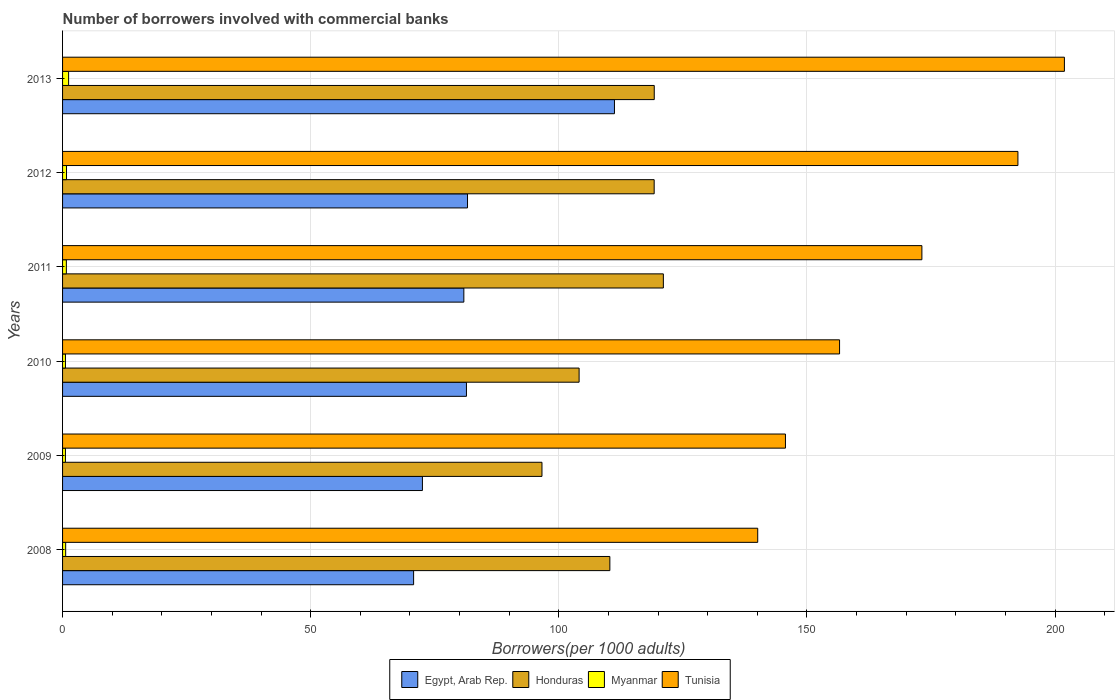How many different coloured bars are there?
Make the answer very short. 4. How many groups of bars are there?
Make the answer very short. 6. How many bars are there on the 1st tick from the top?
Offer a very short reply. 4. How many bars are there on the 6th tick from the bottom?
Give a very brief answer. 4. What is the number of borrowers involved with commercial banks in Egypt, Arab Rep. in 2010?
Your response must be concise. 81.39. Across all years, what is the maximum number of borrowers involved with commercial banks in Egypt, Arab Rep.?
Keep it short and to the point. 111.22. Across all years, what is the minimum number of borrowers involved with commercial banks in Egypt, Arab Rep.?
Keep it short and to the point. 70.74. In which year was the number of borrowers involved with commercial banks in Myanmar minimum?
Your response must be concise. 2009. What is the total number of borrowers involved with commercial banks in Myanmar in the graph?
Keep it short and to the point. 4.56. What is the difference between the number of borrowers involved with commercial banks in Myanmar in 2008 and that in 2011?
Offer a terse response. -0.14. What is the difference between the number of borrowers involved with commercial banks in Honduras in 2008 and the number of borrowers involved with commercial banks in Egypt, Arab Rep. in 2013?
Ensure brevity in your answer.  -0.93. What is the average number of borrowers involved with commercial banks in Myanmar per year?
Your answer should be compact. 0.76. In the year 2011, what is the difference between the number of borrowers involved with commercial banks in Honduras and number of borrowers involved with commercial banks in Tunisia?
Provide a short and direct response. -52.1. What is the ratio of the number of borrowers involved with commercial banks in Tunisia in 2009 to that in 2012?
Offer a very short reply. 0.76. Is the number of borrowers involved with commercial banks in Tunisia in 2011 less than that in 2013?
Offer a terse response. Yes. What is the difference between the highest and the second highest number of borrowers involved with commercial banks in Tunisia?
Offer a very short reply. 9.37. What is the difference between the highest and the lowest number of borrowers involved with commercial banks in Myanmar?
Provide a short and direct response. 0.64. In how many years, is the number of borrowers involved with commercial banks in Tunisia greater than the average number of borrowers involved with commercial banks in Tunisia taken over all years?
Provide a short and direct response. 3. Is the sum of the number of borrowers involved with commercial banks in Tunisia in 2011 and 2012 greater than the maximum number of borrowers involved with commercial banks in Egypt, Arab Rep. across all years?
Provide a succinct answer. Yes. What does the 4th bar from the top in 2012 represents?
Your answer should be compact. Egypt, Arab Rep. What does the 2nd bar from the bottom in 2013 represents?
Your answer should be very brief. Honduras. Is it the case that in every year, the sum of the number of borrowers involved with commercial banks in Myanmar and number of borrowers involved with commercial banks in Tunisia is greater than the number of borrowers involved with commercial banks in Egypt, Arab Rep.?
Keep it short and to the point. Yes. How many years are there in the graph?
Your response must be concise. 6. What is the difference between two consecutive major ticks on the X-axis?
Keep it short and to the point. 50. Are the values on the major ticks of X-axis written in scientific E-notation?
Your answer should be very brief. No. What is the title of the graph?
Ensure brevity in your answer.  Number of borrowers involved with commercial banks. What is the label or title of the X-axis?
Keep it short and to the point. Borrowers(per 1000 adults). What is the Borrowers(per 1000 adults) of Egypt, Arab Rep. in 2008?
Offer a very short reply. 70.74. What is the Borrowers(per 1000 adults) of Honduras in 2008?
Provide a succinct answer. 110.29. What is the Borrowers(per 1000 adults) of Myanmar in 2008?
Your answer should be compact. 0.63. What is the Borrowers(per 1000 adults) in Tunisia in 2008?
Keep it short and to the point. 140.09. What is the Borrowers(per 1000 adults) of Egypt, Arab Rep. in 2009?
Ensure brevity in your answer.  72.52. What is the Borrowers(per 1000 adults) of Honduras in 2009?
Provide a succinct answer. 96.61. What is the Borrowers(per 1000 adults) of Myanmar in 2009?
Give a very brief answer. 0.58. What is the Borrowers(per 1000 adults) of Tunisia in 2009?
Offer a terse response. 145.68. What is the Borrowers(per 1000 adults) of Egypt, Arab Rep. in 2010?
Keep it short and to the point. 81.39. What is the Borrowers(per 1000 adults) in Honduras in 2010?
Ensure brevity in your answer.  104.09. What is the Borrowers(per 1000 adults) of Myanmar in 2010?
Make the answer very short. 0.58. What is the Borrowers(per 1000 adults) in Tunisia in 2010?
Your answer should be compact. 156.58. What is the Borrowers(per 1000 adults) in Egypt, Arab Rep. in 2011?
Your response must be concise. 80.87. What is the Borrowers(per 1000 adults) of Honduras in 2011?
Give a very brief answer. 121.07. What is the Borrowers(per 1000 adults) in Myanmar in 2011?
Your answer should be very brief. 0.76. What is the Borrowers(per 1000 adults) in Tunisia in 2011?
Provide a short and direct response. 173.17. What is the Borrowers(per 1000 adults) of Egypt, Arab Rep. in 2012?
Offer a terse response. 81.61. What is the Borrowers(per 1000 adults) in Honduras in 2012?
Provide a short and direct response. 119.22. What is the Borrowers(per 1000 adults) in Myanmar in 2012?
Give a very brief answer. 0.8. What is the Borrowers(per 1000 adults) in Tunisia in 2012?
Your answer should be very brief. 192.52. What is the Borrowers(per 1000 adults) in Egypt, Arab Rep. in 2013?
Ensure brevity in your answer.  111.22. What is the Borrowers(per 1000 adults) of Honduras in 2013?
Your answer should be very brief. 119.24. What is the Borrowers(per 1000 adults) of Myanmar in 2013?
Give a very brief answer. 1.22. What is the Borrowers(per 1000 adults) of Tunisia in 2013?
Make the answer very short. 201.89. Across all years, what is the maximum Borrowers(per 1000 adults) of Egypt, Arab Rep.?
Ensure brevity in your answer.  111.22. Across all years, what is the maximum Borrowers(per 1000 adults) of Honduras?
Keep it short and to the point. 121.07. Across all years, what is the maximum Borrowers(per 1000 adults) of Myanmar?
Your response must be concise. 1.22. Across all years, what is the maximum Borrowers(per 1000 adults) in Tunisia?
Provide a succinct answer. 201.89. Across all years, what is the minimum Borrowers(per 1000 adults) of Egypt, Arab Rep.?
Give a very brief answer. 70.74. Across all years, what is the minimum Borrowers(per 1000 adults) in Honduras?
Provide a short and direct response. 96.61. Across all years, what is the minimum Borrowers(per 1000 adults) in Myanmar?
Ensure brevity in your answer.  0.58. Across all years, what is the minimum Borrowers(per 1000 adults) of Tunisia?
Provide a succinct answer. 140.09. What is the total Borrowers(per 1000 adults) in Egypt, Arab Rep. in the graph?
Your response must be concise. 498.34. What is the total Borrowers(per 1000 adults) of Honduras in the graph?
Your response must be concise. 670.52. What is the total Borrowers(per 1000 adults) in Myanmar in the graph?
Your answer should be compact. 4.56. What is the total Borrowers(per 1000 adults) of Tunisia in the graph?
Offer a very short reply. 1009.93. What is the difference between the Borrowers(per 1000 adults) of Egypt, Arab Rep. in 2008 and that in 2009?
Offer a very short reply. -1.78. What is the difference between the Borrowers(per 1000 adults) of Honduras in 2008 and that in 2009?
Ensure brevity in your answer.  13.68. What is the difference between the Borrowers(per 1000 adults) in Myanmar in 2008 and that in 2009?
Make the answer very short. 0.05. What is the difference between the Borrowers(per 1000 adults) in Tunisia in 2008 and that in 2009?
Offer a terse response. -5.59. What is the difference between the Borrowers(per 1000 adults) in Egypt, Arab Rep. in 2008 and that in 2010?
Provide a succinct answer. -10.65. What is the difference between the Borrowers(per 1000 adults) in Honduras in 2008 and that in 2010?
Ensure brevity in your answer.  6.2. What is the difference between the Borrowers(per 1000 adults) of Myanmar in 2008 and that in 2010?
Provide a short and direct response. 0.04. What is the difference between the Borrowers(per 1000 adults) in Tunisia in 2008 and that in 2010?
Provide a succinct answer. -16.49. What is the difference between the Borrowers(per 1000 adults) in Egypt, Arab Rep. in 2008 and that in 2011?
Make the answer very short. -10.12. What is the difference between the Borrowers(per 1000 adults) of Honduras in 2008 and that in 2011?
Your answer should be very brief. -10.78. What is the difference between the Borrowers(per 1000 adults) in Myanmar in 2008 and that in 2011?
Ensure brevity in your answer.  -0.14. What is the difference between the Borrowers(per 1000 adults) of Tunisia in 2008 and that in 2011?
Give a very brief answer. -33.08. What is the difference between the Borrowers(per 1000 adults) in Egypt, Arab Rep. in 2008 and that in 2012?
Your response must be concise. -10.86. What is the difference between the Borrowers(per 1000 adults) in Honduras in 2008 and that in 2012?
Offer a terse response. -8.93. What is the difference between the Borrowers(per 1000 adults) in Myanmar in 2008 and that in 2012?
Your answer should be compact. -0.17. What is the difference between the Borrowers(per 1000 adults) in Tunisia in 2008 and that in 2012?
Your answer should be very brief. -52.43. What is the difference between the Borrowers(per 1000 adults) in Egypt, Arab Rep. in 2008 and that in 2013?
Your response must be concise. -40.47. What is the difference between the Borrowers(per 1000 adults) in Honduras in 2008 and that in 2013?
Give a very brief answer. -8.95. What is the difference between the Borrowers(per 1000 adults) of Myanmar in 2008 and that in 2013?
Provide a short and direct response. -0.59. What is the difference between the Borrowers(per 1000 adults) in Tunisia in 2008 and that in 2013?
Give a very brief answer. -61.8. What is the difference between the Borrowers(per 1000 adults) of Egypt, Arab Rep. in 2009 and that in 2010?
Give a very brief answer. -8.87. What is the difference between the Borrowers(per 1000 adults) in Honduras in 2009 and that in 2010?
Your response must be concise. -7.48. What is the difference between the Borrowers(per 1000 adults) of Myanmar in 2009 and that in 2010?
Make the answer very short. -0. What is the difference between the Borrowers(per 1000 adults) of Tunisia in 2009 and that in 2010?
Provide a succinct answer. -10.9. What is the difference between the Borrowers(per 1000 adults) of Egypt, Arab Rep. in 2009 and that in 2011?
Ensure brevity in your answer.  -8.35. What is the difference between the Borrowers(per 1000 adults) in Honduras in 2009 and that in 2011?
Offer a terse response. -24.46. What is the difference between the Borrowers(per 1000 adults) of Myanmar in 2009 and that in 2011?
Your response must be concise. -0.19. What is the difference between the Borrowers(per 1000 adults) in Tunisia in 2009 and that in 2011?
Your answer should be very brief. -27.5. What is the difference between the Borrowers(per 1000 adults) in Egypt, Arab Rep. in 2009 and that in 2012?
Ensure brevity in your answer.  -9.09. What is the difference between the Borrowers(per 1000 adults) in Honduras in 2009 and that in 2012?
Your response must be concise. -22.61. What is the difference between the Borrowers(per 1000 adults) of Myanmar in 2009 and that in 2012?
Offer a very short reply. -0.22. What is the difference between the Borrowers(per 1000 adults) of Tunisia in 2009 and that in 2012?
Give a very brief answer. -46.85. What is the difference between the Borrowers(per 1000 adults) of Egypt, Arab Rep. in 2009 and that in 2013?
Offer a terse response. -38.7. What is the difference between the Borrowers(per 1000 adults) in Honduras in 2009 and that in 2013?
Make the answer very short. -22.63. What is the difference between the Borrowers(per 1000 adults) in Myanmar in 2009 and that in 2013?
Your answer should be very brief. -0.64. What is the difference between the Borrowers(per 1000 adults) in Tunisia in 2009 and that in 2013?
Your response must be concise. -56.21. What is the difference between the Borrowers(per 1000 adults) of Egypt, Arab Rep. in 2010 and that in 2011?
Make the answer very short. 0.52. What is the difference between the Borrowers(per 1000 adults) in Honduras in 2010 and that in 2011?
Your answer should be very brief. -16.98. What is the difference between the Borrowers(per 1000 adults) in Myanmar in 2010 and that in 2011?
Your response must be concise. -0.18. What is the difference between the Borrowers(per 1000 adults) in Tunisia in 2010 and that in 2011?
Make the answer very short. -16.59. What is the difference between the Borrowers(per 1000 adults) in Egypt, Arab Rep. in 2010 and that in 2012?
Provide a short and direct response. -0.21. What is the difference between the Borrowers(per 1000 adults) in Honduras in 2010 and that in 2012?
Make the answer very short. -15.13. What is the difference between the Borrowers(per 1000 adults) of Myanmar in 2010 and that in 2012?
Make the answer very short. -0.21. What is the difference between the Borrowers(per 1000 adults) in Tunisia in 2010 and that in 2012?
Offer a terse response. -35.94. What is the difference between the Borrowers(per 1000 adults) of Egypt, Arab Rep. in 2010 and that in 2013?
Keep it short and to the point. -29.82. What is the difference between the Borrowers(per 1000 adults) of Honduras in 2010 and that in 2013?
Your answer should be very brief. -15.14. What is the difference between the Borrowers(per 1000 adults) in Myanmar in 2010 and that in 2013?
Give a very brief answer. -0.64. What is the difference between the Borrowers(per 1000 adults) of Tunisia in 2010 and that in 2013?
Offer a very short reply. -45.31. What is the difference between the Borrowers(per 1000 adults) in Egypt, Arab Rep. in 2011 and that in 2012?
Offer a terse response. -0.74. What is the difference between the Borrowers(per 1000 adults) in Honduras in 2011 and that in 2012?
Give a very brief answer. 1.85. What is the difference between the Borrowers(per 1000 adults) in Myanmar in 2011 and that in 2012?
Ensure brevity in your answer.  -0.03. What is the difference between the Borrowers(per 1000 adults) in Tunisia in 2011 and that in 2012?
Provide a short and direct response. -19.35. What is the difference between the Borrowers(per 1000 adults) in Egypt, Arab Rep. in 2011 and that in 2013?
Your answer should be very brief. -30.35. What is the difference between the Borrowers(per 1000 adults) of Honduras in 2011 and that in 2013?
Keep it short and to the point. 1.84. What is the difference between the Borrowers(per 1000 adults) of Myanmar in 2011 and that in 2013?
Provide a short and direct response. -0.45. What is the difference between the Borrowers(per 1000 adults) in Tunisia in 2011 and that in 2013?
Offer a terse response. -28.72. What is the difference between the Borrowers(per 1000 adults) in Egypt, Arab Rep. in 2012 and that in 2013?
Offer a terse response. -29.61. What is the difference between the Borrowers(per 1000 adults) in Honduras in 2012 and that in 2013?
Your answer should be very brief. -0.02. What is the difference between the Borrowers(per 1000 adults) in Myanmar in 2012 and that in 2013?
Provide a short and direct response. -0.42. What is the difference between the Borrowers(per 1000 adults) in Tunisia in 2012 and that in 2013?
Your answer should be compact. -9.37. What is the difference between the Borrowers(per 1000 adults) of Egypt, Arab Rep. in 2008 and the Borrowers(per 1000 adults) of Honduras in 2009?
Offer a very short reply. -25.87. What is the difference between the Borrowers(per 1000 adults) in Egypt, Arab Rep. in 2008 and the Borrowers(per 1000 adults) in Myanmar in 2009?
Make the answer very short. 70.17. What is the difference between the Borrowers(per 1000 adults) in Egypt, Arab Rep. in 2008 and the Borrowers(per 1000 adults) in Tunisia in 2009?
Provide a succinct answer. -74.93. What is the difference between the Borrowers(per 1000 adults) in Honduras in 2008 and the Borrowers(per 1000 adults) in Myanmar in 2009?
Offer a terse response. 109.71. What is the difference between the Borrowers(per 1000 adults) in Honduras in 2008 and the Borrowers(per 1000 adults) in Tunisia in 2009?
Keep it short and to the point. -35.38. What is the difference between the Borrowers(per 1000 adults) in Myanmar in 2008 and the Borrowers(per 1000 adults) in Tunisia in 2009?
Offer a very short reply. -145.05. What is the difference between the Borrowers(per 1000 adults) in Egypt, Arab Rep. in 2008 and the Borrowers(per 1000 adults) in Honduras in 2010?
Make the answer very short. -33.35. What is the difference between the Borrowers(per 1000 adults) in Egypt, Arab Rep. in 2008 and the Borrowers(per 1000 adults) in Myanmar in 2010?
Give a very brief answer. 70.16. What is the difference between the Borrowers(per 1000 adults) in Egypt, Arab Rep. in 2008 and the Borrowers(per 1000 adults) in Tunisia in 2010?
Give a very brief answer. -85.84. What is the difference between the Borrowers(per 1000 adults) of Honduras in 2008 and the Borrowers(per 1000 adults) of Myanmar in 2010?
Offer a terse response. 109.71. What is the difference between the Borrowers(per 1000 adults) of Honduras in 2008 and the Borrowers(per 1000 adults) of Tunisia in 2010?
Give a very brief answer. -46.29. What is the difference between the Borrowers(per 1000 adults) of Myanmar in 2008 and the Borrowers(per 1000 adults) of Tunisia in 2010?
Your response must be concise. -155.95. What is the difference between the Borrowers(per 1000 adults) in Egypt, Arab Rep. in 2008 and the Borrowers(per 1000 adults) in Honduras in 2011?
Your answer should be compact. -50.33. What is the difference between the Borrowers(per 1000 adults) of Egypt, Arab Rep. in 2008 and the Borrowers(per 1000 adults) of Myanmar in 2011?
Give a very brief answer. 69.98. What is the difference between the Borrowers(per 1000 adults) of Egypt, Arab Rep. in 2008 and the Borrowers(per 1000 adults) of Tunisia in 2011?
Ensure brevity in your answer.  -102.43. What is the difference between the Borrowers(per 1000 adults) of Honduras in 2008 and the Borrowers(per 1000 adults) of Myanmar in 2011?
Provide a short and direct response. 109.53. What is the difference between the Borrowers(per 1000 adults) in Honduras in 2008 and the Borrowers(per 1000 adults) in Tunisia in 2011?
Offer a terse response. -62.88. What is the difference between the Borrowers(per 1000 adults) in Myanmar in 2008 and the Borrowers(per 1000 adults) in Tunisia in 2011?
Offer a very short reply. -172.55. What is the difference between the Borrowers(per 1000 adults) in Egypt, Arab Rep. in 2008 and the Borrowers(per 1000 adults) in Honduras in 2012?
Provide a succinct answer. -48.48. What is the difference between the Borrowers(per 1000 adults) of Egypt, Arab Rep. in 2008 and the Borrowers(per 1000 adults) of Myanmar in 2012?
Provide a short and direct response. 69.95. What is the difference between the Borrowers(per 1000 adults) in Egypt, Arab Rep. in 2008 and the Borrowers(per 1000 adults) in Tunisia in 2012?
Ensure brevity in your answer.  -121.78. What is the difference between the Borrowers(per 1000 adults) in Honduras in 2008 and the Borrowers(per 1000 adults) in Myanmar in 2012?
Ensure brevity in your answer.  109.49. What is the difference between the Borrowers(per 1000 adults) in Honduras in 2008 and the Borrowers(per 1000 adults) in Tunisia in 2012?
Provide a short and direct response. -82.23. What is the difference between the Borrowers(per 1000 adults) in Myanmar in 2008 and the Borrowers(per 1000 adults) in Tunisia in 2012?
Make the answer very short. -191.9. What is the difference between the Borrowers(per 1000 adults) in Egypt, Arab Rep. in 2008 and the Borrowers(per 1000 adults) in Honduras in 2013?
Offer a very short reply. -48.49. What is the difference between the Borrowers(per 1000 adults) of Egypt, Arab Rep. in 2008 and the Borrowers(per 1000 adults) of Myanmar in 2013?
Offer a very short reply. 69.53. What is the difference between the Borrowers(per 1000 adults) of Egypt, Arab Rep. in 2008 and the Borrowers(per 1000 adults) of Tunisia in 2013?
Offer a terse response. -131.15. What is the difference between the Borrowers(per 1000 adults) of Honduras in 2008 and the Borrowers(per 1000 adults) of Myanmar in 2013?
Your answer should be compact. 109.07. What is the difference between the Borrowers(per 1000 adults) of Honduras in 2008 and the Borrowers(per 1000 adults) of Tunisia in 2013?
Offer a terse response. -91.6. What is the difference between the Borrowers(per 1000 adults) in Myanmar in 2008 and the Borrowers(per 1000 adults) in Tunisia in 2013?
Provide a succinct answer. -201.26. What is the difference between the Borrowers(per 1000 adults) in Egypt, Arab Rep. in 2009 and the Borrowers(per 1000 adults) in Honduras in 2010?
Give a very brief answer. -31.57. What is the difference between the Borrowers(per 1000 adults) in Egypt, Arab Rep. in 2009 and the Borrowers(per 1000 adults) in Myanmar in 2010?
Your answer should be very brief. 71.94. What is the difference between the Borrowers(per 1000 adults) of Egypt, Arab Rep. in 2009 and the Borrowers(per 1000 adults) of Tunisia in 2010?
Offer a terse response. -84.06. What is the difference between the Borrowers(per 1000 adults) in Honduras in 2009 and the Borrowers(per 1000 adults) in Myanmar in 2010?
Your answer should be compact. 96.03. What is the difference between the Borrowers(per 1000 adults) of Honduras in 2009 and the Borrowers(per 1000 adults) of Tunisia in 2010?
Offer a very short reply. -59.97. What is the difference between the Borrowers(per 1000 adults) of Myanmar in 2009 and the Borrowers(per 1000 adults) of Tunisia in 2010?
Provide a short and direct response. -156. What is the difference between the Borrowers(per 1000 adults) of Egypt, Arab Rep. in 2009 and the Borrowers(per 1000 adults) of Honduras in 2011?
Your response must be concise. -48.55. What is the difference between the Borrowers(per 1000 adults) of Egypt, Arab Rep. in 2009 and the Borrowers(per 1000 adults) of Myanmar in 2011?
Make the answer very short. 71.75. What is the difference between the Borrowers(per 1000 adults) of Egypt, Arab Rep. in 2009 and the Borrowers(per 1000 adults) of Tunisia in 2011?
Your answer should be very brief. -100.65. What is the difference between the Borrowers(per 1000 adults) in Honduras in 2009 and the Borrowers(per 1000 adults) in Myanmar in 2011?
Your response must be concise. 95.84. What is the difference between the Borrowers(per 1000 adults) in Honduras in 2009 and the Borrowers(per 1000 adults) in Tunisia in 2011?
Make the answer very short. -76.56. What is the difference between the Borrowers(per 1000 adults) in Myanmar in 2009 and the Borrowers(per 1000 adults) in Tunisia in 2011?
Your answer should be compact. -172.59. What is the difference between the Borrowers(per 1000 adults) in Egypt, Arab Rep. in 2009 and the Borrowers(per 1000 adults) in Honduras in 2012?
Your answer should be compact. -46.7. What is the difference between the Borrowers(per 1000 adults) of Egypt, Arab Rep. in 2009 and the Borrowers(per 1000 adults) of Myanmar in 2012?
Your response must be concise. 71.72. What is the difference between the Borrowers(per 1000 adults) in Egypt, Arab Rep. in 2009 and the Borrowers(per 1000 adults) in Tunisia in 2012?
Offer a very short reply. -120. What is the difference between the Borrowers(per 1000 adults) of Honduras in 2009 and the Borrowers(per 1000 adults) of Myanmar in 2012?
Provide a short and direct response. 95.81. What is the difference between the Borrowers(per 1000 adults) of Honduras in 2009 and the Borrowers(per 1000 adults) of Tunisia in 2012?
Give a very brief answer. -95.91. What is the difference between the Borrowers(per 1000 adults) of Myanmar in 2009 and the Borrowers(per 1000 adults) of Tunisia in 2012?
Give a very brief answer. -191.95. What is the difference between the Borrowers(per 1000 adults) of Egypt, Arab Rep. in 2009 and the Borrowers(per 1000 adults) of Honduras in 2013?
Keep it short and to the point. -46.72. What is the difference between the Borrowers(per 1000 adults) of Egypt, Arab Rep. in 2009 and the Borrowers(per 1000 adults) of Myanmar in 2013?
Ensure brevity in your answer.  71.3. What is the difference between the Borrowers(per 1000 adults) in Egypt, Arab Rep. in 2009 and the Borrowers(per 1000 adults) in Tunisia in 2013?
Provide a succinct answer. -129.37. What is the difference between the Borrowers(per 1000 adults) in Honduras in 2009 and the Borrowers(per 1000 adults) in Myanmar in 2013?
Your response must be concise. 95.39. What is the difference between the Borrowers(per 1000 adults) of Honduras in 2009 and the Borrowers(per 1000 adults) of Tunisia in 2013?
Your answer should be compact. -105.28. What is the difference between the Borrowers(per 1000 adults) of Myanmar in 2009 and the Borrowers(per 1000 adults) of Tunisia in 2013?
Ensure brevity in your answer.  -201.31. What is the difference between the Borrowers(per 1000 adults) in Egypt, Arab Rep. in 2010 and the Borrowers(per 1000 adults) in Honduras in 2011?
Your answer should be compact. -39.68. What is the difference between the Borrowers(per 1000 adults) in Egypt, Arab Rep. in 2010 and the Borrowers(per 1000 adults) in Myanmar in 2011?
Your response must be concise. 80.63. What is the difference between the Borrowers(per 1000 adults) of Egypt, Arab Rep. in 2010 and the Borrowers(per 1000 adults) of Tunisia in 2011?
Your answer should be compact. -91.78. What is the difference between the Borrowers(per 1000 adults) of Honduras in 2010 and the Borrowers(per 1000 adults) of Myanmar in 2011?
Provide a succinct answer. 103.33. What is the difference between the Borrowers(per 1000 adults) in Honduras in 2010 and the Borrowers(per 1000 adults) in Tunisia in 2011?
Give a very brief answer. -69.08. What is the difference between the Borrowers(per 1000 adults) in Myanmar in 2010 and the Borrowers(per 1000 adults) in Tunisia in 2011?
Give a very brief answer. -172.59. What is the difference between the Borrowers(per 1000 adults) in Egypt, Arab Rep. in 2010 and the Borrowers(per 1000 adults) in Honduras in 2012?
Your answer should be compact. -37.83. What is the difference between the Borrowers(per 1000 adults) in Egypt, Arab Rep. in 2010 and the Borrowers(per 1000 adults) in Myanmar in 2012?
Offer a terse response. 80.59. What is the difference between the Borrowers(per 1000 adults) in Egypt, Arab Rep. in 2010 and the Borrowers(per 1000 adults) in Tunisia in 2012?
Keep it short and to the point. -111.13. What is the difference between the Borrowers(per 1000 adults) in Honduras in 2010 and the Borrowers(per 1000 adults) in Myanmar in 2012?
Ensure brevity in your answer.  103.3. What is the difference between the Borrowers(per 1000 adults) of Honduras in 2010 and the Borrowers(per 1000 adults) of Tunisia in 2012?
Your response must be concise. -88.43. What is the difference between the Borrowers(per 1000 adults) of Myanmar in 2010 and the Borrowers(per 1000 adults) of Tunisia in 2012?
Keep it short and to the point. -191.94. What is the difference between the Borrowers(per 1000 adults) in Egypt, Arab Rep. in 2010 and the Borrowers(per 1000 adults) in Honduras in 2013?
Ensure brevity in your answer.  -37.85. What is the difference between the Borrowers(per 1000 adults) in Egypt, Arab Rep. in 2010 and the Borrowers(per 1000 adults) in Myanmar in 2013?
Offer a terse response. 80.17. What is the difference between the Borrowers(per 1000 adults) of Egypt, Arab Rep. in 2010 and the Borrowers(per 1000 adults) of Tunisia in 2013?
Your answer should be compact. -120.5. What is the difference between the Borrowers(per 1000 adults) in Honduras in 2010 and the Borrowers(per 1000 adults) in Myanmar in 2013?
Offer a very short reply. 102.88. What is the difference between the Borrowers(per 1000 adults) of Honduras in 2010 and the Borrowers(per 1000 adults) of Tunisia in 2013?
Your answer should be compact. -97.8. What is the difference between the Borrowers(per 1000 adults) in Myanmar in 2010 and the Borrowers(per 1000 adults) in Tunisia in 2013?
Keep it short and to the point. -201.31. What is the difference between the Borrowers(per 1000 adults) of Egypt, Arab Rep. in 2011 and the Borrowers(per 1000 adults) of Honduras in 2012?
Ensure brevity in your answer.  -38.35. What is the difference between the Borrowers(per 1000 adults) in Egypt, Arab Rep. in 2011 and the Borrowers(per 1000 adults) in Myanmar in 2012?
Ensure brevity in your answer.  80.07. What is the difference between the Borrowers(per 1000 adults) of Egypt, Arab Rep. in 2011 and the Borrowers(per 1000 adults) of Tunisia in 2012?
Offer a terse response. -111.66. What is the difference between the Borrowers(per 1000 adults) of Honduras in 2011 and the Borrowers(per 1000 adults) of Myanmar in 2012?
Your answer should be very brief. 120.28. What is the difference between the Borrowers(per 1000 adults) of Honduras in 2011 and the Borrowers(per 1000 adults) of Tunisia in 2012?
Provide a short and direct response. -71.45. What is the difference between the Borrowers(per 1000 adults) of Myanmar in 2011 and the Borrowers(per 1000 adults) of Tunisia in 2012?
Provide a succinct answer. -191.76. What is the difference between the Borrowers(per 1000 adults) in Egypt, Arab Rep. in 2011 and the Borrowers(per 1000 adults) in Honduras in 2013?
Keep it short and to the point. -38.37. What is the difference between the Borrowers(per 1000 adults) of Egypt, Arab Rep. in 2011 and the Borrowers(per 1000 adults) of Myanmar in 2013?
Your answer should be very brief. 79.65. What is the difference between the Borrowers(per 1000 adults) in Egypt, Arab Rep. in 2011 and the Borrowers(per 1000 adults) in Tunisia in 2013?
Ensure brevity in your answer.  -121.02. What is the difference between the Borrowers(per 1000 adults) in Honduras in 2011 and the Borrowers(per 1000 adults) in Myanmar in 2013?
Ensure brevity in your answer.  119.86. What is the difference between the Borrowers(per 1000 adults) of Honduras in 2011 and the Borrowers(per 1000 adults) of Tunisia in 2013?
Offer a terse response. -80.82. What is the difference between the Borrowers(per 1000 adults) in Myanmar in 2011 and the Borrowers(per 1000 adults) in Tunisia in 2013?
Keep it short and to the point. -201.13. What is the difference between the Borrowers(per 1000 adults) in Egypt, Arab Rep. in 2012 and the Borrowers(per 1000 adults) in Honduras in 2013?
Your response must be concise. -37.63. What is the difference between the Borrowers(per 1000 adults) in Egypt, Arab Rep. in 2012 and the Borrowers(per 1000 adults) in Myanmar in 2013?
Provide a succinct answer. 80.39. What is the difference between the Borrowers(per 1000 adults) of Egypt, Arab Rep. in 2012 and the Borrowers(per 1000 adults) of Tunisia in 2013?
Offer a very short reply. -120.28. What is the difference between the Borrowers(per 1000 adults) in Honduras in 2012 and the Borrowers(per 1000 adults) in Myanmar in 2013?
Your answer should be very brief. 118. What is the difference between the Borrowers(per 1000 adults) in Honduras in 2012 and the Borrowers(per 1000 adults) in Tunisia in 2013?
Your answer should be very brief. -82.67. What is the difference between the Borrowers(per 1000 adults) of Myanmar in 2012 and the Borrowers(per 1000 adults) of Tunisia in 2013?
Your response must be concise. -201.09. What is the average Borrowers(per 1000 adults) in Egypt, Arab Rep. per year?
Make the answer very short. 83.06. What is the average Borrowers(per 1000 adults) of Honduras per year?
Provide a short and direct response. 111.75. What is the average Borrowers(per 1000 adults) of Myanmar per year?
Provide a succinct answer. 0.76. What is the average Borrowers(per 1000 adults) of Tunisia per year?
Your answer should be very brief. 168.32. In the year 2008, what is the difference between the Borrowers(per 1000 adults) of Egypt, Arab Rep. and Borrowers(per 1000 adults) of Honduras?
Ensure brevity in your answer.  -39.55. In the year 2008, what is the difference between the Borrowers(per 1000 adults) in Egypt, Arab Rep. and Borrowers(per 1000 adults) in Myanmar?
Provide a succinct answer. 70.12. In the year 2008, what is the difference between the Borrowers(per 1000 adults) of Egypt, Arab Rep. and Borrowers(per 1000 adults) of Tunisia?
Your answer should be compact. -69.34. In the year 2008, what is the difference between the Borrowers(per 1000 adults) of Honduras and Borrowers(per 1000 adults) of Myanmar?
Keep it short and to the point. 109.66. In the year 2008, what is the difference between the Borrowers(per 1000 adults) in Honduras and Borrowers(per 1000 adults) in Tunisia?
Make the answer very short. -29.8. In the year 2008, what is the difference between the Borrowers(per 1000 adults) of Myanmar and Borrowers(per 1000 adults) of Tunisia?
Offer a terse response. -139.46. In the year 2009, what is the difference between the Borrowers(per 1000 adults) in Egypt, Arab Rep. and Borrowers(per 1000 adults) in Honduras?
Offer a terse response. -24.09. In the year 2009, what is the difference between the Borrowers(per 1000 adults) of Egypt, Arab Rep. and Borrowers(per 1000 adults) of Myanmar?
Your answer should be very brief. 71.94. In the year 2009, what is the difference between the Borrowers(per 1000 adults) in Egypt, Arab Rep. and Borrowers(per 1000 adults) in Tunisia?
Give a very brief answer. -73.16. In the year 2009, what is the difference between the Borrowers(per 1000 adults) of Honduras and Borrowers(per 1000 adults) of Myanmar?
Provide a succinct answer. 96.03. In the year 2009, what is the difference between the Borrowers(per 1000 adults) in Honduras and Borrowers(per 1000 adults) in Tunisia?
Your answer should be compact. -49.07. In the year 2009, what is the difference between the Borrowers(per 1000 adults) in Myanmar and Borrowers(per 1000 adults) in Tunisia?
Give a very brief answer. -145.1. In the year 2010, what is the difference between the Borrowers(per 1000 adults) of Egypt, Arab Rep. and Borrowers(per 1000 adults) of Honduras?
Offer a very short reply. -22.7. In the year 2010, what is the difference between the Borrowers(per 1000 adults) in Egypt, Arab Rep. and Borrowers(per 1000 adults) in Myanmar?
Give a very brief answer. 80.81. In the year 2010, what is the difference between the Borrowers(per 1000 adults) in Egypt, Arab Rep. and Borrowers(per 1000 adults) in Tunisia?
Offer a very short reply. -75.19. In the year 2010, what is the difference between the Borrowers(per 1000 adults) of Honduras and Borrowers(per 1000 adults) of Myanmar?
Ensure brevity in your answer.  103.51. In the year 2010, what is the difference between the Borrowers(per 1000 adults) in Honduras and Borrowers(per 1000 adults) in Tunisia?
Give a very brief answer. -52.49. In the year 2010, what is the difference between the Borrowers(per 1000 adults) in Myanmar and Borrowers(per 1000 adults) in Tunisia?
Your answer should be compact. -156. In the year 2011, what is the difference between the Borrowers(per 1000 adults) of Egypt, Arab Rep. and Borrowers(per 1000 adults) of Honduras?
Keep it short and to the point. -40.21. In the year 2011, what is the difference between the Borrowers(per 1000 adults) in Egypt, Arab Rep. and Borrowers(per 1000 adults) in Myanmar?
Provide a short and direct response. 80.1. In the year 2011, what is the difference between the Borrowers(per 1000 adults) of Egypt, Arab Rep. and Borrowers(per 1000 adults) of Tunisia?
Your answer should be very brief. -92.3. In the year 2011, what is the difference between the Borrowers(per 1000 adults) in Honduras and Borrowers(per 1000 adults) in Myanmar?
Your answer should be compact. 120.31. In the year 2011, what is the difference between the Borrowers(per 1000 adults) in Honduras and Borrowers(per 1000 adults) in Tunisia?
Provide a succinct answer. -52.1. In the year 2011, what is the difference between the Borrowers(per 1000 adults) of Myanmar and Borrowers(per 1000 adults) of Tunisia?
Give a very brief answer. -172.41. In the year 2012, what is the difference between the Borrowers(per 1000 adults) of Egypt, Arab Rep. and Borrowers(per 1000 adults) of Honduras?
Keep it short and to the point. -37.62. In the year 2012, what is the difference between the Borrowers(per 1000 adults) in Egypt, Arab Rep. and Borrowers(per 1000 adults) in Myanmar?
Offer a very short reply. 80.81. In the year 2012, what is the difference between the Borrowers(per 1000 adults) of Egypt, Arab Rep. and Borrowers(per 1000 adults) of Tunisia?
Make the answer very short. -110.92. In the year 2012, what is the difference between the Borrowers(per 1000 adults) of Honduras and Borrowers(per 1000 adults) of Myanmar?
Make the answer very short. 118.43. In the year 2012, what is the difference between the Borrowers(per 1000 adults) in Honduras and Borrowers(per 1000 adults) in Tunisia?
Give a very brief answer. -73.3. In the year 2012, what is the difference between the Borrowers(per 1000 adults) in Myanmar and Borrowers(per 1000 adults) in Tunisia?
Offer a very short reply. -191.73. In the year 2013, what is the difference between the Borrowers(per 1000 adults) of Egypt, Arab Rep. and Borrowers(per 1000 adults) of Honduras?
Ensure brevity in your answer.  -8.02. In the year 2013, what is the difference between the Borrowers(per 1000 adults) of Egypt, Arab Rep. and Borrowers(per 1000 adults) of Myanmar?
Offer a terse response. 110. In the year 2013, what is the difference between the Borrowers(per 1000 adults) of Egypt, Arab Rep. and Borrowers(per 1000 adults) of Tunisia?
Ensure brevity in your answer.  -90.67. In the year 2013, what is the difference between the Borrowers(per 1000 adults) of Honduras and Borrowers(per 1000 adults) of Myanmar?
Keep it short and to the point. 118.02. In the year 2013, what is the difference between the Borrowers(per 1000 adults) of Honduras and Borrowers(per 1000 adults) of Tunisia?
Keep it short and to the point. -82.65. In the year 2013, what is the difference between the Borrowers(per 1000 adults) of Myanmar and Borrowers(per 1000 adults) of Tunisia?
Give a very brief answer. -200.67. What is the ratio of the Borrowers(per 1000 adults) in Egypt, Arab Rep. in 2008 to that in 2009?
Ensure brevity in your answer.  0.98. What is the ratio of the Borrowers(per 1000 adults) in Honduras in 2008 to that in 2009?
Keep it short and to the point. 1.14. What is the ratio of the Borrowers(per 1000 adults) of Myanmar in 2008 to that in 2009?
Offer a very short reply. 1.08. What is the ratio of the Borrowers(per 1000 adults) in Tunisia in 2008 to that in 2009?
Provide a short and direct response. 0.96. What is the ratio of the Borrowers(per 1000 adults) of Egypt, Arab Rep. in 2008 to that in 2010?
Your response must be concise. 0.87. What is the ratio of the Borrowers(per 1000 adults) of Honduras in 2008 to that in 2010?
Give a very brief answer. 1.06. What is the ratio of the Borrowers(per 1000 adults) of Myanmar in 2008 to that in 2010?
Make the answer very short. 1.08. What is the ratio of the Borrowers(per 1000 adults) in Tunisia in 2008 to that in 2010?
Give a very brief answer. 0.89. What is the ratio of the Borrowers(per 1000 adults) in Egypt, Arab Rep. in 2008 to that in 2011?
Ensure brevity in your answer.  0.87. What is the ratio of the Borrowers(per 1000 adults) in Honduras in 2008 to that in 2011?
Provide a succinct answer. 0.91. What is the ratio of the Borrowers(per 1000 adults) in Myanmar in 2008 to that in 2011?
Your answer should be compact. 0.82. What is the ratio of the Borrowers(per 1000 adults) in Tunisia in 2008 to that in 2011?
Provide a succinct answer. 0.81. What is the ratio of the Borrowers(per 1000 adults) of Egypt, Arab Rep. in 2008 to that in 2012?
Your answer should be very brief. 0.87. What is the ratio of the Borrowers(per 1000 adults) in Honduras in 2008 to that in 2012?
Give a very brief answer. 0.93. What is the ratio of the Borrowers(per 1000 adults) of Myanmar in 2008 to that in 2012?
Make the answer very short. 0.79. What is the ratio of the Borrowers(per 1000 adults) of Tunisia in 2008 to that in 2012?
Offer a very short reply. 0.73. What is the ratio of the Borrowers(per 1000 adults) of Egypt, Arab Rep. in 2008 to that in 2013?
Your response must be concise. 0.64. What is the ratio of the Borrowers(per 1000 adults) of Honduras in 2008 to that in 2013?
Your response must be concise. 0.93. What is the ratio of the Borrowers(per 1000 adults) of Myanmar in 2008 to that in 2013?
Make the answer very short. 0.51. What is the ratio of the Borrowers(per 1000 adults) in Tunisia in 2008 to that in 2013?
Give a very brief answer. 0.69. What is the ratio of the Borrowers(per 1000 adults) of Egypt, Arab Rep. in 2009 to that in 2010?
Your answer should be compact. 0.89. What is the ratio of the Borrowers(per 1000 adults) in Honduras in 2009 to that in 2010?
Offer a very short reply. 0.93. What is the ratio of the Borrowers(per 1000 adults) of Myanmar in 2009 to that in 2010?
Offer a terse response. 0.99. What is the ratio of the Borrowers(per 1000 adults) in Tunisia in 2009 to that in 2010?
Keep it short and to the point. 0.93. What is the ratio of the Borrowers(per 1000 adults) of Egypt, Arab Rep. in 2009 to that in 2011?
Ensure brevity in your answer.  0.9. What is the ratio of the Borrowers(per 1000 adults) in Honduras in 2009 to that in 2011?
Offer a very short reply. 0.8. What is the ratio of the Borrowers(per 1000 adults) in Myanmar in 2009 to that in 2011?
Make the answer very short. 0.76. What is the ratio of the Borrowers(per 1000 adults) in Tunisia in 2009 to that in 2011?
Give a very brief answer. 0.84. What is the ratio of the Borrowers(per 1000 adults) of Egypt, Arab Rep. in 2009 to that in 2012?
Make the answer very short. 0.89. What is the ratio of the Borrowers(per 1000 adults) in Honduras in 2009 to that in 2012?
Offer a very short reply. 0.81. What is the ratio of the Borrowers(per 1000 adults) of Myanmar in 2009 to that in 2012?
Ensure brevity in your answer.  0.73. What is the ratio of the Borrowers(per 1000 adults) in Tunisia in 2009 to that in 2012?
Provide a short and direct response. 0.76. What is the ratio of the Borrowers(per 1000 adults) of Egypt, Arab Rep. in 2009 to that in 2013?
Provide a succinct answer. 0.65. What is the ratio of the Borrowers(per 1000 adults) of Honduras in 2009 to that in 2013?
Make the answer very short. 0.81. What is the ratio of the Borrowers(per 1000 adults) in Myanmar in 2009 to that in 2013?
Your answer should be very brief. 0.47. What is the ratio of the Borrowers(per 1000 adults) of Tunisia in 2009 to that in 2013?
Make the answer very short. 0.72. What is the ratio of the Borrowers(per 1000 adults) of Egypt, Arab Rep. in 2010 to that in 2011?
Provide a short and direct response. 1.01. What is the ratio of the Borrowers(per 1000 adults) in Honduras in 2010 to that in 2011?
Provide a short and direct response. 0.86. What is the ratio of the Borrowers(per 1000 adults) in Myanmar in 2010 to that in 2011?
Your response must be concise. 0.76. What is the ratio of the Borrowers(per 1000 adults) in Tunisia in 2010 to that in 2011?
Provide a succinct answer. 0.9. What is the ratio of the Borrowers(per 1000 adults) of Egypt, Arab Rep. in 2010 to that in 2012?
Keep it short and to the point. 1. What is the ratio of the Borrowers(per 1000 adults) in Honduras in 2010 to that in 2012?
Your response must be concise. 0.87. What is the ratio of the Borrowers(per 1000 adults) in Myanmar in 2010 to that in 2012?
Offer a very short reply. 0.73. What is the ratio of the Borrowers(per 1000 adults) of Tunisia in 2010 to that in 2012?
Your response must be concise. 0.81. What is the ratio of the Borrowers(per 1000 adults) of Egypt, Arab Rep. in 2010 to that in 2013?
Offer a very short reply. 0.73. What is the ratio of the Borrowers(per 1000 adults) in Honduras in 2010 to that in 2013?
Keep it short and to the point. 0.87. What is the ratio of the Borrowers(per 1000 adults) of Myanmar in 2010 to that in 2013?
Offer a very short reply. 0.48. What is the ratio of the Borrowers(per 1000 adults) in Tunisia in 2010 to that in 2013?
Your answer should be compact. 0.78. What is the ratio of the Borrowers(per 1000 adults) of Egypt, Arab Rep. in 2011 to that in 2012?
Give a very brief answer. 0.99. What is the ratio of the Borrowers(per 1000 adults) in Honduras in 2011 to that in 2012?
Offer a terse response. 1.02. What is the ratio of the Borrowers(per 1000 adults) of Myanmar in 2011 to that in 2012?
Provide a short and direct response. 0.96. What is the ratio of the Borrowers(per 1000 adults) in Tunisia in 2011 to that in 2012?
Offer a terse response. 0.9. What is the ratio of the Borrowers(per 1000 adults) of Egypt, Arab Rep. in 2011 to that in 2013?
Ensure brevity in your answer.  0.73. What is the ratio of the Borrowers(per 1000 adults) in Honduras in 2011 to that in 2013?
Keep it short and to the point. 1.02. What is the ratio of the Borrowers(per 1000 adults) of Myanmar in 2011 to that in 2013?
Keep it short and to the point. 0.63. What is the ratio of the Borrowers(per 1000 adults) in Tunisia in 2011 to that in 2013?
Offer a terse response. 0.86. What is the ratio of the Borrowers(per 1000 adults) in Egypt, Arab Rep. in 2012 to that in 2013?
Your answer should be compact. 0.73. What is the ratio of the Borrowers(per 1000 adults) in Honduras in 2012 to that in 2013?
Give a very brief answer. 1. What is the ratio of the Borrowers(per 1000 adults) in Myanmar in 2012 to that in 2013?
Keep it short and to the point. 0.65. What is the ratio of the Borrowers(per 1000 adults) in Tunisia in 2012 to that in 2013?
Make the answer very short. 0.95. What is the difference between the highest and the second highest Borrowers(per 1000 adults) of Egypt, Arab Rep.?
Ensure brevity in your answer.  29.61. What is the difference between the highest and the second highest Borrowers(per 1000 adults) of Honduras?
Ensure brevity in your answer.  1.84. What is the difference between the highest and the second highest Borrowers(per 1000 adults) of Myanmar?
Keep it short and to the point. 0.42. What is the difference between the highest and the second highest Borrowers(per 1000 adults) of Tunisia?
Your answer should be very brief. 9.37. What is the difference between the highest and the lowest Borrowers(per 1000 adults) of Egypt, Arab Rep.?
Give a very brief answer. 40.47. What is the difference between the highest and the lowest Borrowers(per 1000 adults) of Honduras?
Ensure brevity in your answer.  24.46. What is the difference between the highest and the lowest Borrowers(per 1000 adults) in Myanmar?
Ensure brevity in your answer.  0.64. What is the difference between the highest and the lowest Borrowers(per 1000 adults) of Tunisia?
Your answer should be compact. 61.8. 